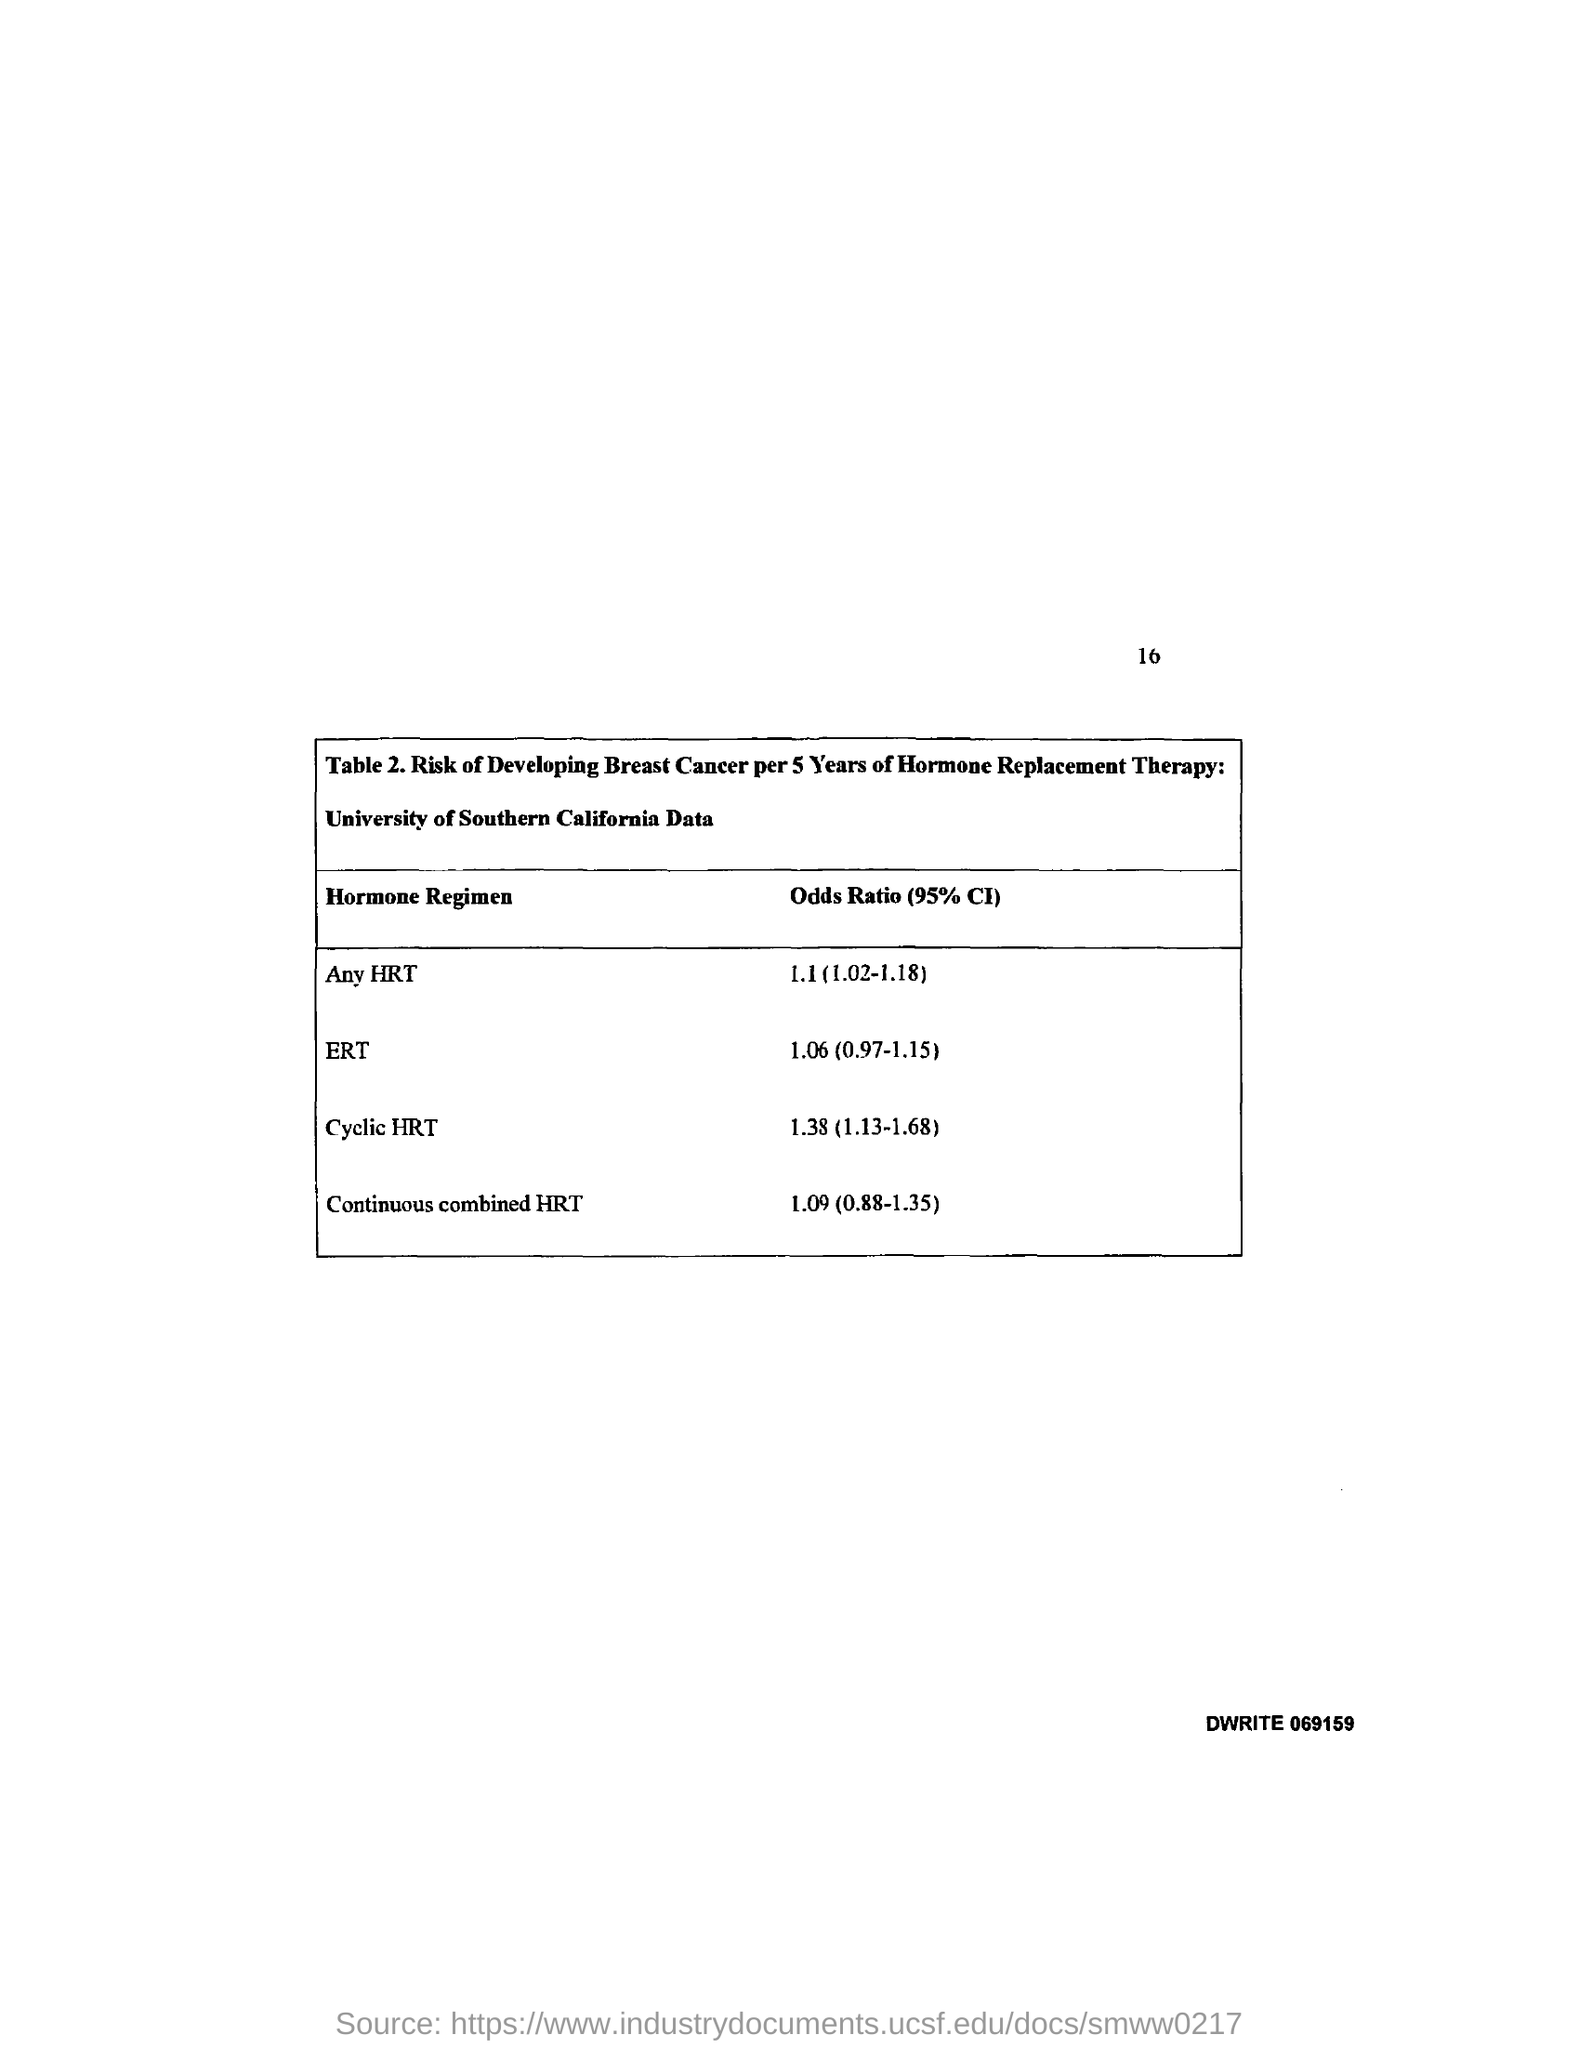What is the Odds Ratio (95% CI) for Any HRT?
Your answer should be very brief. 1.1 (1.02-1.18). What is the Odds Ratio (95% CI) for ERT?
Make the answer very short. 1.06 (0.97-1.15). What is the Odds Ratio (95% CI) for Cyclic HRT?
Your answer should be very brief. 1.38 (1.13-1.68). 